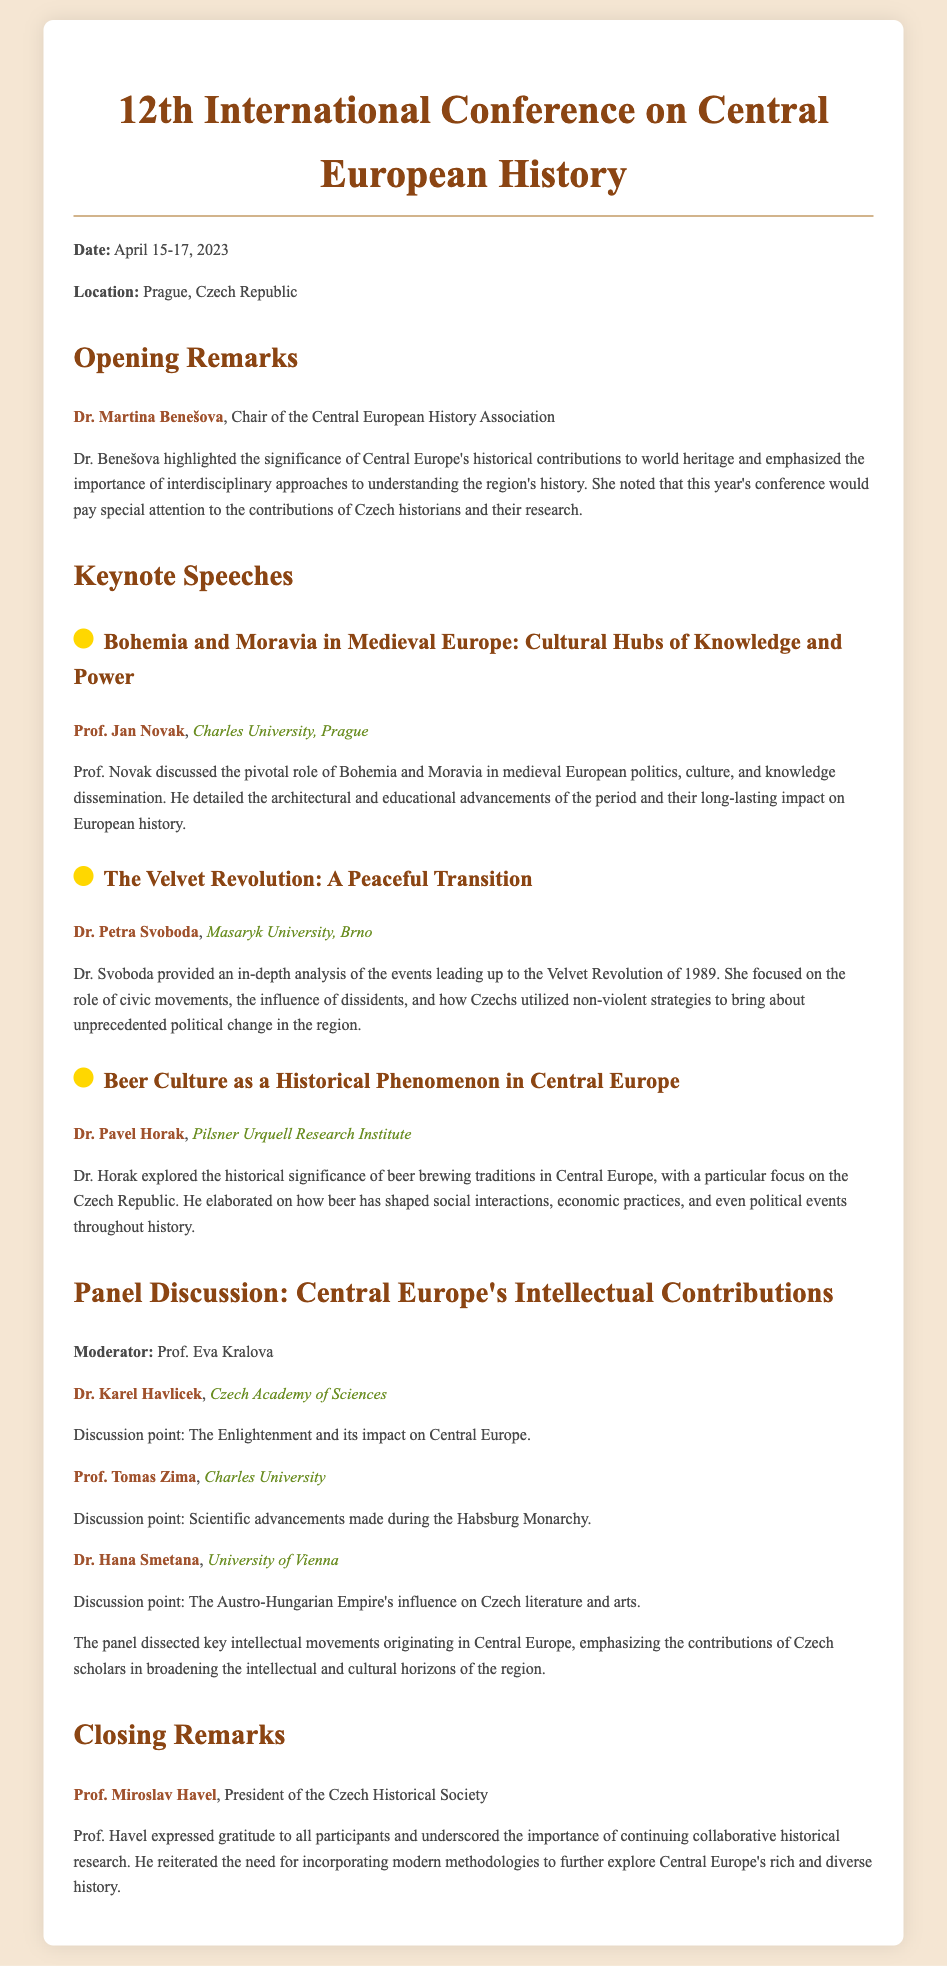What is the date of the conference? The date of the conference is specified at the beginning of the document.
Answer: April 15-17, 2023 Who gave the opening remarks? The speaker of the opening remarks is clearly identified in the document.
Answer: Dr. Martina Benešova What university is Prof. Jan Novak affiliated with? Prof. Jan Novak's affiliation is mentioned next to his name in the keynote section.
Answer: Charles University, Prague Which topic did Dr. Pavel Horak discuss? The title of Dr. Horak's presentation is specified, detailing the subject of his discussion.
Answer: Beer Culture as a Historical Phenomenon in Central Europe How many panel members are listed in the document? The document enumerates the speakers participating in the panel discussion.
Answer: Three What was the focus of Dr. Svoboda's keynote? The document summarizes Dr. Svoboda's research focus in her keynote description.
Answer: Velvet Revolution Who moderated the panel discussion? The name of the moderator is stated before the panel members' descriptions.
Answer: Prof. Eva Kralova What is the name of the institution Dr. Karel Havlicek is affiliated with? Dr. Havlicek's affiliation is given when he is introduced in the panel discussion.
Answer: Czech Academy of Sciences 